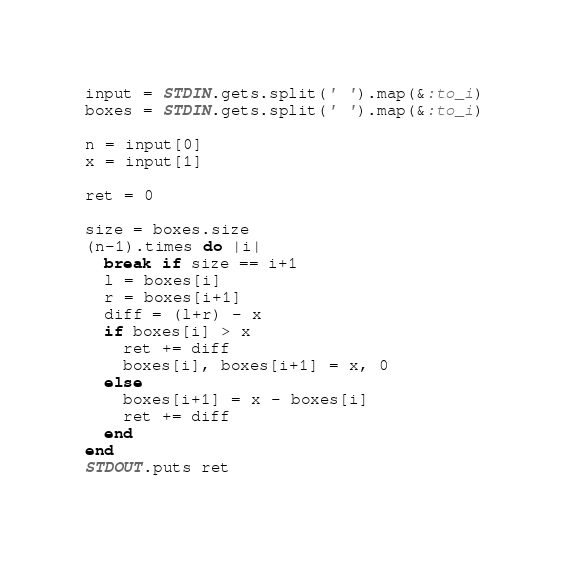Convert code to text. <code><loc_0><loc_0><loc_500><loc_500><_Ruby_>input = STDIN.gets.split(' ').map(&:to_i)
boxes = STDIN.gets.split(' ').map(&:to_i)

n = input[0]
x = input[1]

ret = 0

size = boxes.size
(n-1).times do |i|
  break if size == i+1
  l = boxes[i]
  r = boxes[i+1]
  diff = (l+r) - x
  if boxes[i] > x
    ret += diff
    boxes[i], boxes[i+1] = x, 0
  else
    boxes[i+1] = x - boxes[i]
    ret += diff
  end
end
STDOUT.puts ret</code> 